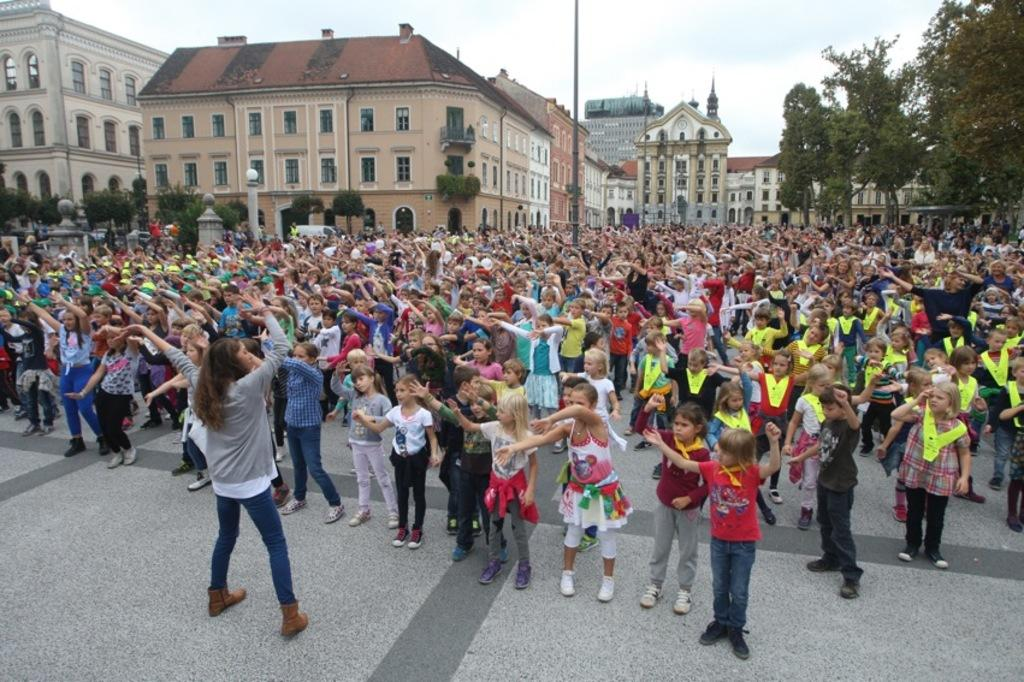What are the people in the image doing? The people in the image are standing on the ground. What can be seen in the distance behind the people? There are buildings, trees, a pole, and the sky visible in the background. What type of tin is being used for the feast in the image? There is no feast or tin present in the image. 